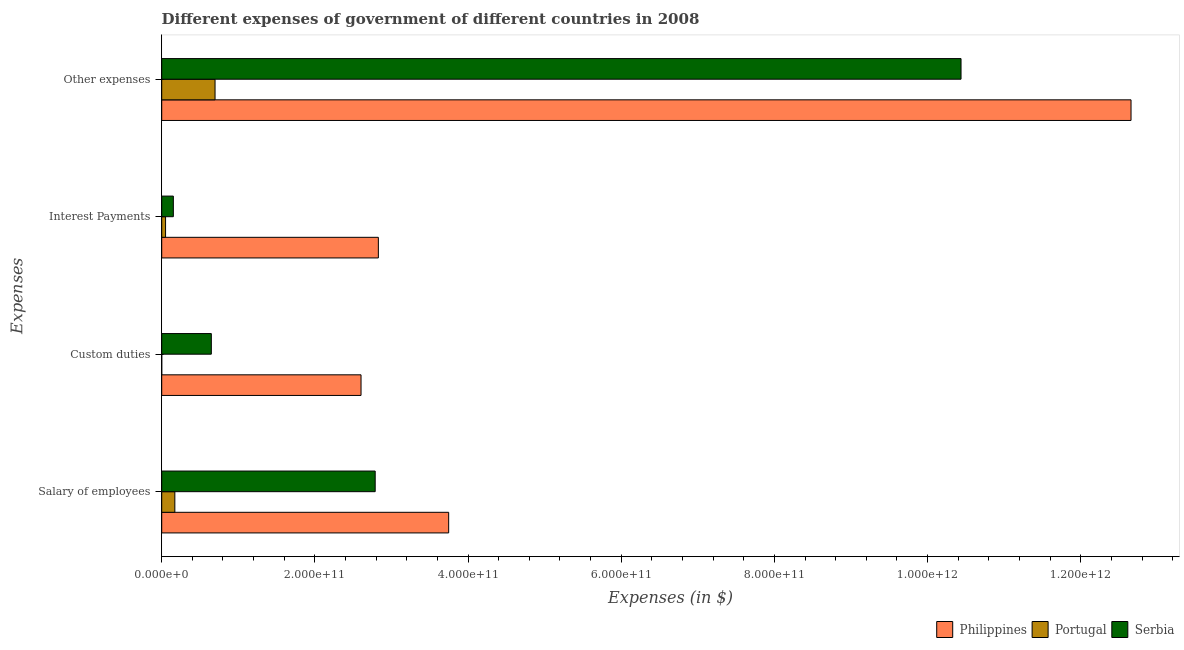Are the number of bars on each tick of the Y-axis equal?
Your answer should be compact. Yes. How many bars are there on the 1st tick from the bottom?
Ensure brevity in your answer.  3. What is the label of the 4th group of bars from the top?
Provide a short and direct response. Salary of employees. What is the amount spent on salary of employees in Philippines?
Provide a short and direct response. 3.75e+11. Across all countries, what is the maximum amount spent on salary of employees?
Provide a succinct answer. 3.75e+11. Across all countries, what is the minimum amount spent on interest payments?
Offer a terse response. 5.02e+09. In which country was the amount spent on salary of employees maximum?
Keep it short and to the point. Philippines. In which country was the amount spent on interest payments minimum?
Provide a short and direct response. Portugal. What is the total amount spent on interest payments in the graph?
Offer a terse response. 3.03e+11. What is the difference between the amount spent on interest payments in Portugal and that in Philippines?
Ensure brevity in your answer.  -2.78e+11. What is the difference between the amount spent on custom duties in Philippines and the amount spent on other expenses in Serbia?
Provide a succinct answer. -7.83e+11. What is the average amount spent on other expenses per country?
Offer a very short reply. 7.93e+11. What is the difference between the amount spent on custom duties and amount spent on salary of employees in Portugal?
Offer a very short reply. -1.72e+1. What is the ratio of the amount spent on interest payments in Serbia to that in Philippines?
Give a very brief answer. 0.05. Is the amount spent on custom duties in Philippines less than that in Portugal?
Offer a very short reply. No. What is the difference between the highest and the second highest amount spent on interest payments?
Your answer should be compact. 2.68e+11. What is the difference between the highest and the lowest amount spent on salary of employees?
Provide a succinct answer. 3.58e+11. Is it the case that in every country, the sum of the amount spent on other expenses and amount spent on interest payments is greater than the sum of amount spent on custom duties and amount spent on salary of employees?
Provide a succinct answer. No. What does the 1st bar from the top in Other expenses represents?
Give a very brief answer. Serbia. What does the 3rd bar from the bottom in Interest Payments represents?
Provide a short and direct response. Serbia. Are all the bars in the graph horizontal?
Provide a succinct answer. Yes. How many countries are there in the graph?
Keep it short and to the point. 3. What is the difference between two consecutive major ticks on the X-axis?
Your answer should be very brief. 2.00e+11. Does the graph contain any zero values?
Give a very brief answer. No. Does the graph contain grids?
Your answer should be very brief. No. Where does the legend appear in the graph?
Offer a very short reply. Bottom right. How many legend labels are there?
Provide a short and direct response. 3. What is the title of the graph?
Give a very brief answer. Different expenses of government of different countries in 2008. What is the label or title of the X-axis?
Offer a very short reply. Expenses (in $). What is the label or title of the Y-axis?
Provide a short and direct response. Expenses. What is the Expenses (in $) in Philippines in Salary of employees?
Provide a succinct answer. 3.75e+11. What is the Expenses (in $) of Portugal in Salary of employees?
Your response must be concise. 1.72e+1. What is the Expenses (in $) in Serbia in Salary of employees?
Offer a very short reply. 2.79e+11. What is the Expenses (in $) in Philippines in Custom duties?
Your answer should be compact. 2.60e+11. What is the Expenses (in $) in Portugal in Custom duties?
Your answer should be compact. 1.09e+06. What is the Expenses (in $) of Serbia in Custom duties?
Your response must be concise. 6.48e+1. What is the Expenses (in $) in Philippines in Interest Payments?
Your answer should be very brief. 2.83e+11. What is the Expenses (in $) in Portugal in Interest Payments?
Your response must be concise. 5.02e+09. What is the Expenses (in $) in Serbia in Interest Payments?
Your answer should be very brief. 1.52e+1. What is the Expenses (in $) of Philippines in Other expenses?
Your answer should be compact. 1.27e+12. What is the Expenses (in $) of Portugal in Other expenses?
Your answer should be compact. 6.96e+1. What is the Expenses (in $) of Serbia in Other expenses?
Your answer should be compact. 1.04e+12. Across all Expenses, what is the maximum Expenses (in $) in Philippines?
Offer a very short reply. 1.27e+12. Across all Expenses, what is the maximum Expenses (in $) of Portugal?
Keep it short and to the point. 6.96e+1. Across all Expenses, what is the maximum Expenses (in $) in Serbia?
Give a very brief answer. 1.04e+12. Across all Expenses, what is the minimum Expenses (in $) of Philippines?
Give a very brief answer. 2.60e+11. Across all Expenses, what is the minimum Expenses (in $) in Portugal?
Your answer should be very brief. 1.09e+06. Across all Expenses, what is the minimum Expenses (in $) in Serbia?
Make the answer very short. 1.52e+1. What is the total Expenses (in $) of Philippines in the graph?
Keep it short and to the point. 2.18e+12. What is the total Expenses (in $) of Portugal in the graph?
Provide a succinct answer. 9.18e+1. What is the total Expenses (in $) of Serbia in the graph?
Your answer should be compact. 1.40e+12. What is the difference between the Expenses (in $) of Philippines in Salary of employees and that in Custom duties?
Ensure brevity in your answer.  1.14e+11. What is the difference between the Expenses (in $) of Portugal in Salary of employees and that in Custom duties?
Make the answer very short. 1.72e+1. What is the difference between the Expenses (in $) of Serbia in Salary of employees and that in Custom duties?
Your answer should be compact. 2.14e+11. What is the difference between the Expenses (in $) in Philippines in Salary of employees and that in Interest Payments?
Keep it short and to the point. 9.18e+1. What is the difference between the Expenses (in $) of Portugal in Salary of employees and that in Interest Payments?
Keep it short and to the point. 1.21e+1. What is the difference between the Expenses (in $) in Serbia in Salary of employees and that in Interest Payments?
Make the answer very short. 2.64e+11. What is the difference between the Expenses (in $) of Philippines in Salary of employees and that in Other expenses?
Offer a terse response. -8.91e+11. What is the difference between the Expenses (in $) of Portugal in Salary of employees and that in Other expenses?
Make the answer very short. -5.25e+1. What is the difference between the Expenses (in $) of Serbia in Salary of employees and that in Other expenses?
Offer a terse response. -7.65e+11. What is the difference between the Expenses (in $) of Philippines in Custom duties and that in Interest Payments?
Keep it short and to the point. -2.26e+1. What is the difference between the Expenses (in $) of Portugal in Custom duties and that in Interest Payments?
Give a very brief answer. -5.02e+09. What is the difference between the Expenses (in $) in Serbia in Custom duties and that in Interest Payments?
Keep it short and to the point. 4.96e+1. What is the difference between the Expenses (in $) in Philippines in Custom duties and that in Other expenses?
Your response must be concise. -1.01e+12. What is the difference between the Expenses (in $) of Portugal in Custom duties and that in Other expenses?
Offer a terse response. -6.96e+1. What is the difference between the Expenses (in $) of Serbia in Custom duties and that in Other expenses?
Your response must be concise. -9.79e+11. What is the difference between the Expenses (in $) in Philippines in Interest Payments and that in Other expenses?
Your answer should be compact. -9.83e+11. What is the difference between the Expenses (in $) in Portugal in Interest Payments and that in Other expenses?
Provide a succinct answer. -6.46e+1. What is the difference between the Expenses (in $) in Serbia in Interest Payments and that in Other expenses?
Ensure brevity in your answer.  -1.03e+12. What is the difference between the Expenses (in $) in Philippines in Salary of employees and the Expenses (in $) in Portugal in Custom duties?
Offer a very short reply. 3.75e+11. What is the difference between the Expenses (in $) in Philippines in Salary of employees and the Expenses (in $) in Serbia in Custom duties?
Make the answer very short. 3.10e+11. What is the difference between the Expenses (in $) in Portugal in Salary of employees and the Expenses (in $) in Serbia in Custom duties?
Make the answer very short. -4.76e+1. What is the difference between the Expenses (in $) in Philippines in Salary of employees and the Expenses (in $) in Portugal in Interest Payments?
Offer a terse response. 3.70e+11. What is the difference between the Expenses (in $) of Philippines in Salary of employees and the Expenses (in $) of Serbia in Interest Payments?
Your response must be concise. 3.59e+11. What is the difference between the Expenses (in $) of Portugal in Salary of employees and the Expenses (in $) of Serbia in Interest Payments?
Your answer should be compact. 1.97e+09. What is the difference between the Expenses (in $) in Philippines in Salary of employees and the Expenses (in $) in Portugal in Other expenses?
Make the answer very short. 3.05e+11. What is the difference between the Expenses (in $) of Philippines in Salary of employees and the Expenses (in $) of Serbia in Other expenses?
Offer a terse response. -6.69e+11. What is the difference between the Expenses (in $) of Portugal in Salary of employees and the Expenses (in $) of Serbia in Other expenses?
Your response must be concise. -1.03e+12. What is the difference between the Expenses (in $) of Philippines in Custom duties and the Expenses (in $) of Portugal in Interest Payments?
Offer a very short reply. 2.55e+11. What is the difference between the Expenses (in $) in Philippines in Custom duties and the Expenses (in $) in Serbia in Interest Payments?
Your answer should be very brief. 2.45e+11. What is the difference between the Expenses (in $) of Portugal in Custom duties and the Expenses (in $) of Serbia in Interest Payments?
Offer a terse response. -1.52e+1. What is the difference between the Expenses (in $) in Philippines in Custom duties and the Expenses (in $) in Portugal in Other expenses?
Provide a succinct answer. 1.91e+11. What is the difference between the Expenses (in $) in Philippines in Custom duties and the Expenses (in $) in Serbia in Other expenses?
Keep it short and to the point. -7.83e+11. What is the difference between the Expenses (in $) in Portugal in Custom duties and the Expenses (in $) in Serbia in Other expenses?
Offer a very short reply. -1.04e+12. What is the difference between the Expenses (in $) of Philippines in Interest Payments and the Expenses (in $) of Portugal in Other expenses?
Make the answer very short. 2.13e+11. What is the difference between the Expenses (in $) in Philippines in Interest Payments and the Expenses (in $) in Serbia in Other expenses?
Give a very brief answer. -7.61e+11. What is the difference between the Expenses (in $) of Portugal in Interest Payments and the Expenses (in $) of Serbia in Other expenses?
Your answer should be very brief. -1.04e+12. What is the average Expenses (in $) in Philippines per Expenses?
Make the answer very short. 5.46e+11. What is the average Expenses (in $) in Portugal per Expenses?
Provide a succinct answer. 2.30e+1. What is the average Expenses (in $) in Serbia per Expenses?
Provide a short and direct response. 3.51e+11. What is the difference between the Expenses (in $) of Philippines and Expenses (in $) of Portugal in Salary of employees?
Provide a succinct answer. 3.58e+11. What is the difference between the Expenses (in $) of Philippines and Expenses (in $) of Serbia in Salary of employees?
Your answer should be very brief. 9.59e+1. What is the difference between the Expenses (in $) of Portugal and Expenses (in $) of Serbia in Salary of employees?
Provide a succinct answer. -2.62e+11. What is the difference between the Expenses (in $) of Philippines and Expenses (in $) of Portugal in Custom duties?
Keep it short and to the point. 2.60e+11. What is the difference between the Expenses (in $) of Philippines and Expenses (in $) of Serbia in Custom duties?
Your response must be concise. 1.95e+11. What is the difference between the Expenses (in $) in Portugal and Expenses (in $) in Serbia in Custom duties?
Keep it short and to the point. -6.48e+1. What is the difference between the Expenses (in $) in Philippines and Expenses (in $) in Portugal in Interest Payments?
Make the answer very short. 2.78e+11. What is the difference between the Expenses (in $) in Philippines and Expenses (in $) in Serbia in Interest Payments?
Your answer should be compact. 2.68e+11. What is the difference between the Expenses (in $) of Portugal and Expenses (in $) of Serbia in Interest Payments?
Your response must be concise. -1.02e+1. What is the difference between the Expenses (in $) in Philippines and Expenses (in $) in Portugal in Other expenses?
Ensure brevity in your answer.  1.20e+12. What is the difference between the Expenses (in $) of Philippines and Expenses (in $) of Serbia in Other expenses?
Provide a short and direct response. 2.22e+11. What is the difference between the Expenses (in $) in Portugal and Expenses (in $) in Serbia in Other expenses?
Make the answer very short. -9.74e+11. What is the ratio of the Expenses (in $) of Philippines in Salary of employees to that in Custom duties?
Your answer should be compact. 1.44. What is the ratio of the Expenses (in $) in Portugal in Salary of employees to that in Custom duties?
Your answer should be very brief. 1.57e+04. What is the ratio of the Expenses (in $) of Serbia in Salary of employees to that in Custom duties?
Ensure brevity in your answer.  4.3. What is the ratio of the Expenses (in $) in Philippines in Salary of employees to that in Interest Payments?
Offer a terse response. 1.32. What is the ratio of the Expenses (in $) in Portugal in Salary of employees to that in Interest Payments?
Your answer should be very brief. 3.42. What is the ratio of the Expenses (in $) in Serbia in Salary of employees to that in Interest Payments?
Keep it short and to the point. 18.35. What is the ratio of the Expenses (in $) in Philippines in Salary of employees to that in Other expenses?
Keep it short and to the point. 0.3. What is the ratio of the Expenses (in $) in Portugal in Salary of employees to that in Other expenses?
Provide a short and direct response. 0.25. What is the ratio of the Expenses (in $) in Serbia in Salary of employees to that in Other expenses?
Give a very brief answer. 0.27. What is the ratio of the Expenses (in $) of Philippines in Custom duties to that in Interest Payments?
Your answer should be compact. 0.92. What is the ratio of the Expenses (in $) in Serbia in Custom duties to that in Interest Payments?
Give a very brief answer. 4.27. What is the ratio of the Expenses (in $) in Philippines in Custom duties to that in Other expenses?
Give a very brief answer. 0.21. What is the ratio of the Expenses (in $) in Portugal in Custom duties to that in Other expenses?
Your answer should be compact. 0. What is the ratio of the Expenses (in $) of Serbia in Custom duties to that in Other expenses?
Provide a succinct answer. 0.06. What is the ratio of the Expenses (in $) in Philippines in Interest Payments to that in Other expenses?
Provide a short and direct response. 0.22. What is the ratio of the Expenses (in $) in Portugal in Interest Payments to that in Other expenses?
Offer a very short reply. 0.07. What is the ratio of the Expenses (in $) in Serbia in Interest Payments to that in Other expenses?
Keep it short and to the point. 0.01. What is the difference between the highest and the second highest Expenses (in $) of Philippines?
Provide a succinct answer. 8.91e+11. What is the difference between the highest and the second highest Expenses (in $) in Portugal?
Your response must be concise. 5.25e+1. What is the difference between the highest and the second highest Expenses (in $) of Serbia?
Ensure brevity in your answer.  7.65e+11. What is the difference between the highest and the lowest Expenses (in $) in Philippines?
Your response must be concise. 1.01e+12. What is the difference between the highest and the lowest Expenses (in $) in Portugal?
Offer a terse response. 6.96e+1. What is the difference between the highest and the lowest Expenses (in $) in Serbia?
Provide a short and direct response. 1.03e+12. 